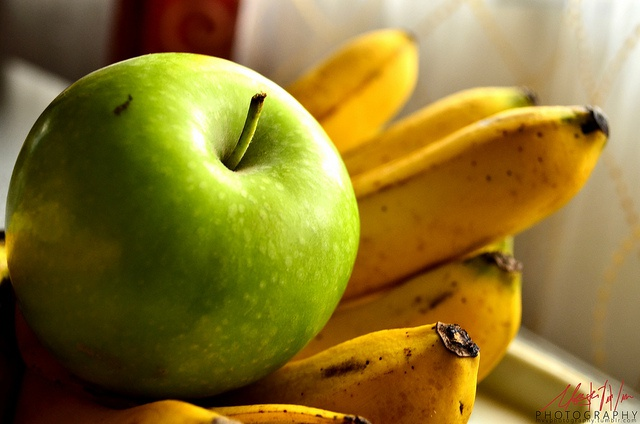Describe the objects in this image and their specific colors. I can see apple in black, olive, and khaki tones and banana in black, olive, orange, and maroon tones in this image. 